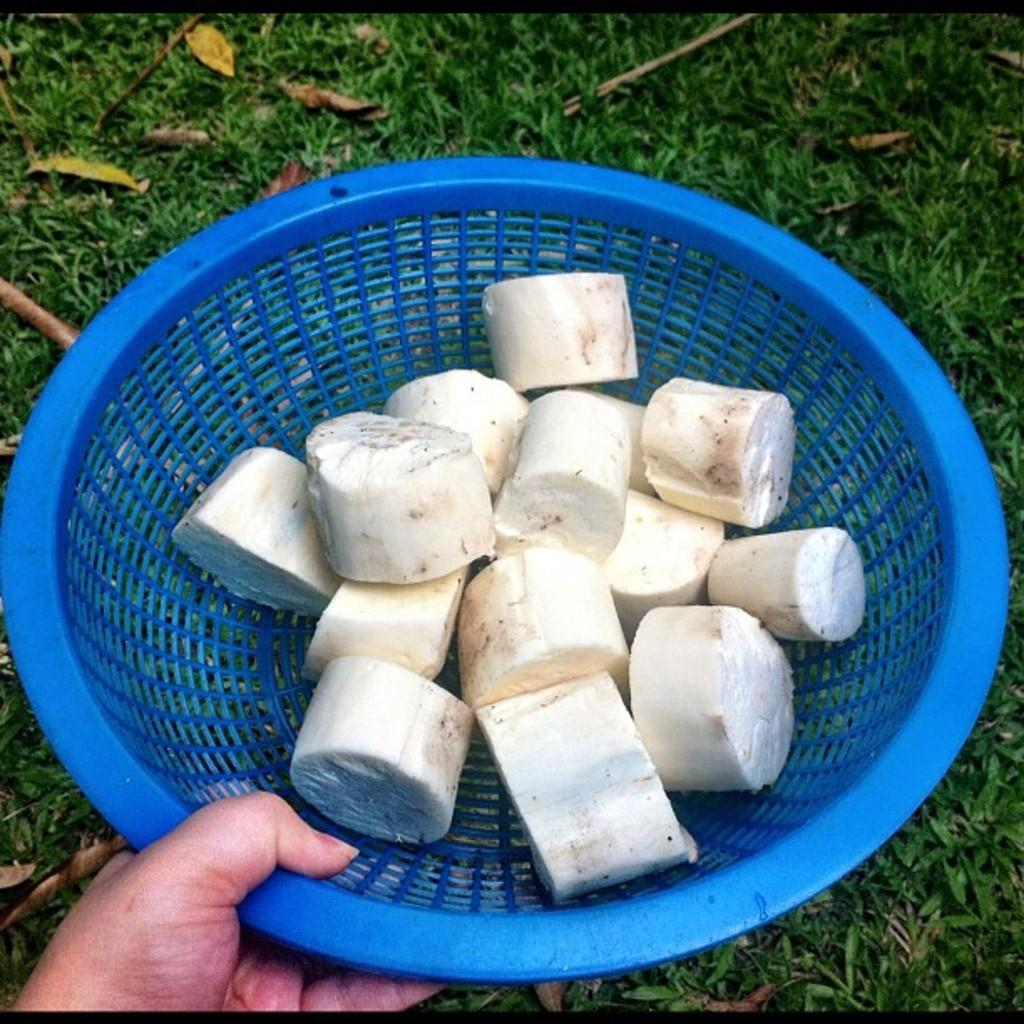What is the person in the image holding? The person is holding a basket in the image. What is inside the basket? There is food in the basket. What can be seen in the background of the image? The grass in the background is green. Can you describe the cat's haircut in the image? There is no cat present in the image, so it is not possible to describe a haircut for a cat. 